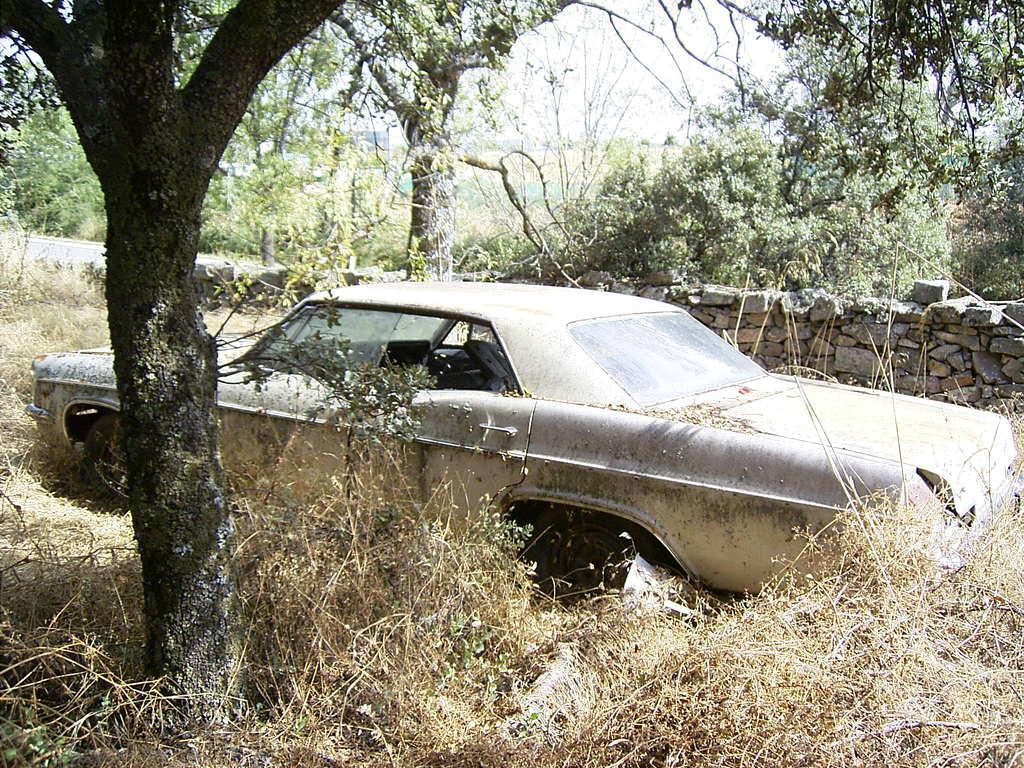What type of vehicle is present in the image? There is an old, unused car in the image. What is located beside the car? There is a tree beside the car. What can be seen in the right corner of the image? There is a rock wall in the right corner of the image. What is visible in the background of the image? There are trees in the background of the image. What type of bread can be seen hanging from the tree in the image? There is no bread present in the image; it features an old, unused car, a tree, a rock wall, and trees in the background. 